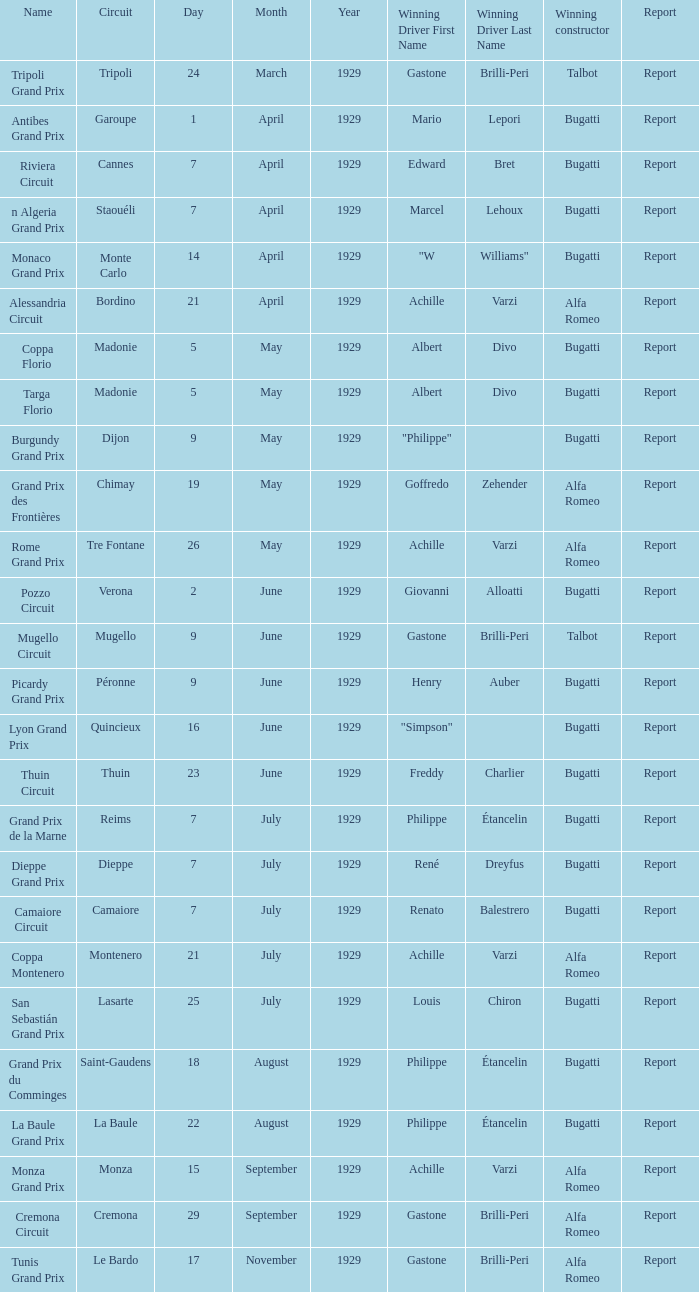What Winning driver has a Name of mugello circuit? Gastone Brilli-Peri. 